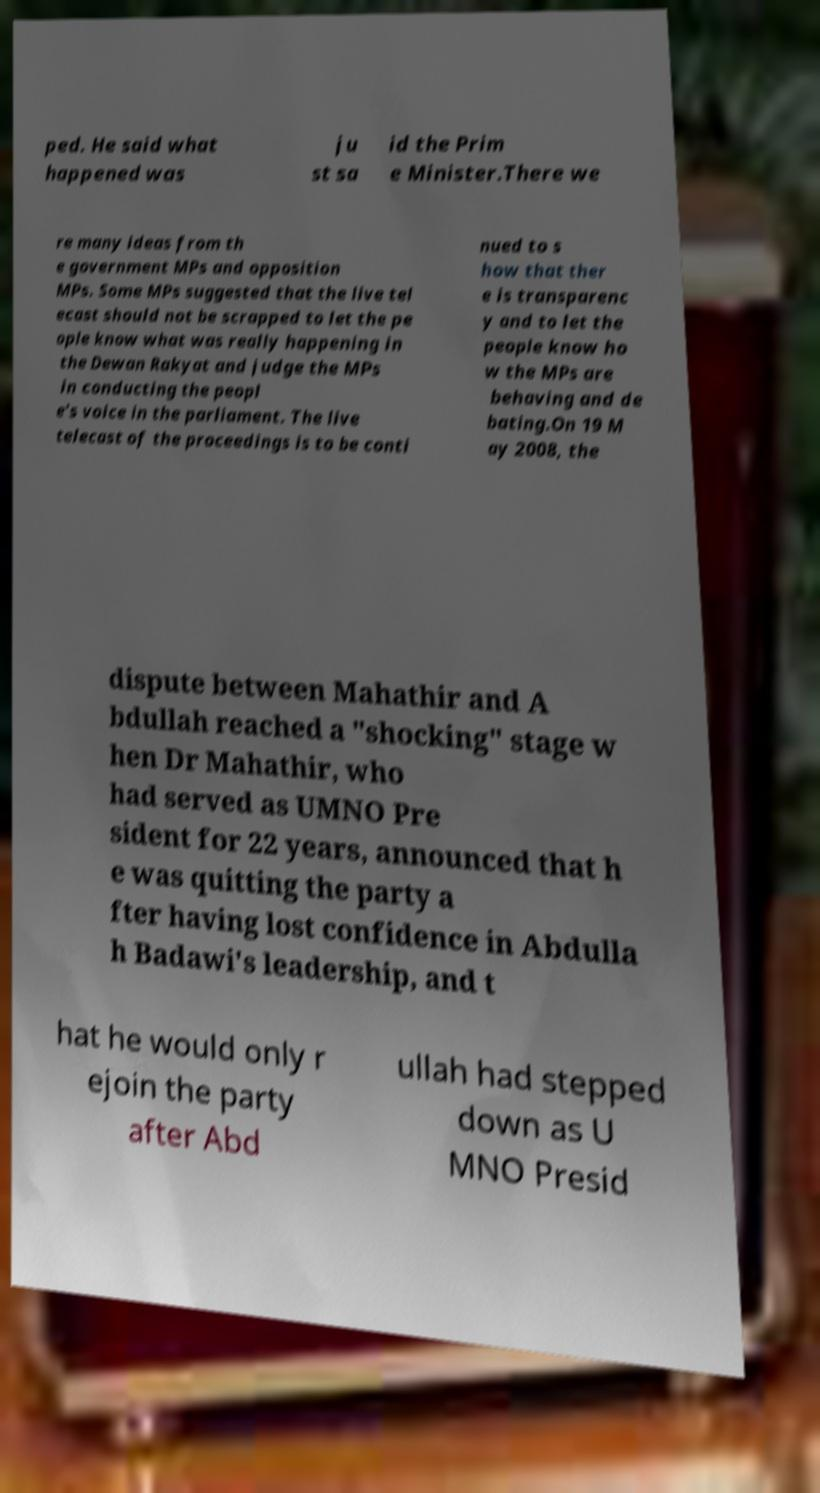Could you assist in decoding the text presented in this image and type it out clearly? ped. He said what happened was ju st sa id the Prim e Minister.There we re many ideas from th e government MPs and opposition MPs. Some MPs suggested that the live tel ecast should not be scrapped to let the pe ople know what was really happening in the Dewan Rakyat and judge the MPs in conducting the peopl e's voice in the parliament. The live telecast of the proceedings is to be conti nued to s how that ther e is transparenc y and to let the people know ho w the MPs are behaving and de bating.On 19 M ay 2008, the dispute between Mahathir and A bdullah reached a "shocking" stage w hen Dr Mahathir, who had served as UMNO Pre sident for 22 years, announced that h e was quitting the party a fter having lost confidence in Abdulla h Badawi's leadership, and t hat he would only r ejoin the party after Abd ullah had stepped down as U MNO Presid 